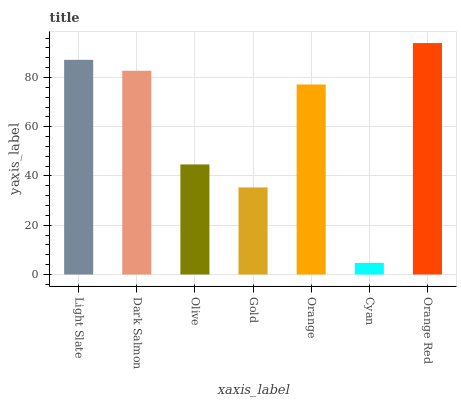Is Cyan the minimum?
Answer yes or no. Yes. Is Orange Red the maximum?
Answer yes or no. Yes. Is Dark Salmon the minimum?
Answer yes or no. No. Is Dark Salmon the maximum?
Answer yes or no. No. Is Light Slate greater than Dark Salmon?
Answer yes or no. Yes. Is Dark Salmon less than Light Slate?
Answer yes or no. Yes. Is Dark Salmon greater than Light Slate?
Answer yes or no. No. Is Light Slate less than Dark Salmon?
Answer yes or no. No. Is Orange the high median?
Answer yes or no. Yes. Is Orange the low median?
Answer yes or no. Yes. Is Olive the high median?
Answer yes or no. No. Is Gold the low median?
Answer yes or no. No. 